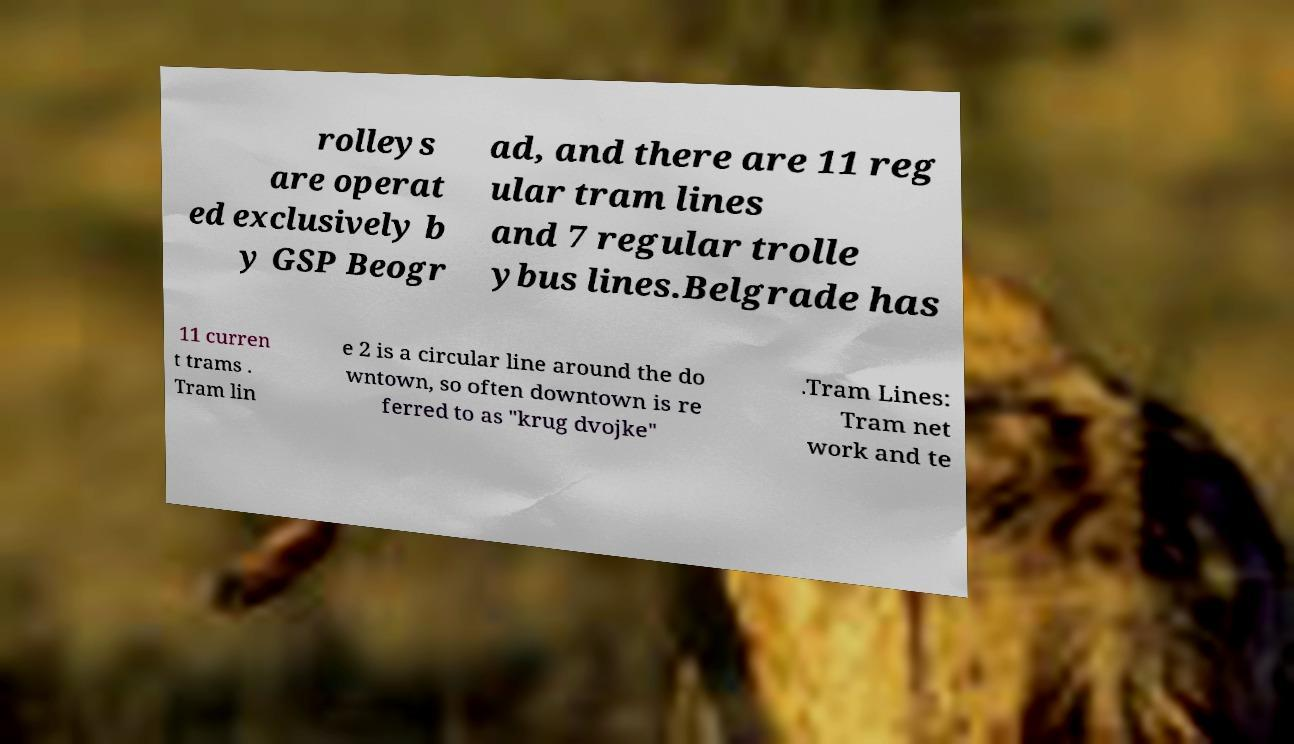Could you extract and type out the text from this image? rolleys are operat ed exclusively b y GSP Beogr ad, and there are 11 reg ular tram lines and 7 regular trolle ybus lines.Belgrade has 11 curren t trams . Tram lin e 2 is a circular line around the do wntown, so often downtown is re ferred to as "krug dvojke" .Tram Lines: Tram net work and te 